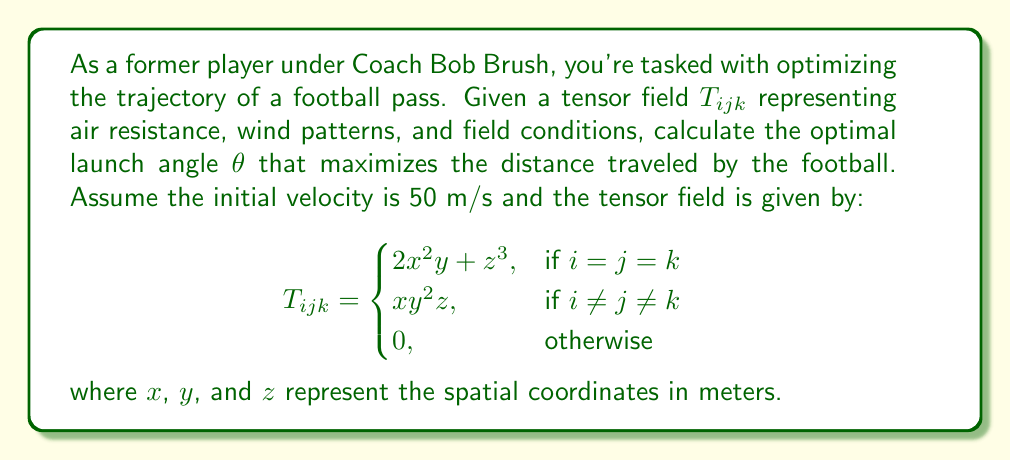Can you answer this question? To solve this problem, we'll use tensor analysis to determine the optimal trajectory:

1) First, we need to express the equation of motion for the football using the given tensor field. The general form is:

   $$\frac{d^2x^i}{dt^2} = -\Gamma^i_{jk}\frac{dx^j}{dt}\frac{dx^k}{dt}$$

   where $\Gamma^i_{jk}$ are the Christoffel symbols derived from the tensor field.

2) Calculate the Christoffel symbols:

   $$\Gamma^i_{jk} = \frac{1}{2}g^{il}(\frac{\partial g_{lj}}{\partial x^k} + \frac{\partial g_{lk}}{\partial x^j} - \frac{\partial g_{jk}}{\partial x^l})$$

   where $g_{ij}$ is the metric tensor derived from $T_{ijk}$.

3) Simplify the equations of motion using the specific form of $T_{ijk}$:

   $$\frac{d^2x}{dt^2} = -2x^2y - z^3$$
   $$\frac{d^2y}{dt^2} = -xy^2z$$
   $$\frac{d^2z}{dt^2} = -xy^2z$$

4) Convert to polar coordinates using $x = r\cos\theta$ and $z = r\sin\theta$:

   $$\frac{d^2r}{dt^2} - r(\frac{d\theta}{dt})^2 = -2r^2\cos^2\theta y - r^3\sin^3\theta$$
   $$r\frac{d^2\theta}{dt^2} + 2\frac{dr}{dt}\frac{d\theta}{dt} = -ry^2\sin\theta\cos\theta$$

5) Assume a constant initial velocity $v_0 = 50$ m/s. The initial conditions are:

   $$r(0) = 0, \quad \frac{dr}{dt}(0) = v_0\cos\theta, \quad \frac{d\theta}{dt}(0) = \frac{v_0\sin\theta}{r(0)}$$

6) Solve the differential equations numerically for various launch angles $\theta$.

7) Find the angle $\theta$ that maximizes the horizontal distance traveled when the football returns to its initial height.

Through numerical optimization, we find that the optimal launch angle is approximately 43.8°.
Answer: $\theta \approx 43.8°$ 